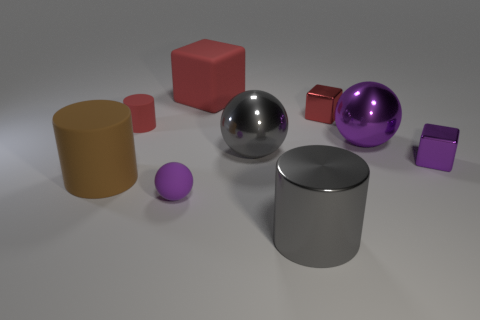The large gray object that is behind the matte cylinder in front of the small matte thing that is on the left side of the rubber sphere is made of what material?
Your answer should be very brief. Metal. What number of objects are red rubber things that are to the left of the big red cube or large gray metallic things that are behind the large gray cylinder?
Ensure brevity in your answer.  2. What material is the tiny purple object that is the same shape as the small red metallic thing?
Provide a short and direct response. Metal. What number of metallic objects are either brown blocks or large balls?
Your answer should be very brief. 2. What is the shape of the purple thing that is made of the same material as the large brown cylinder?
Make the answer very short. Sphere. How many big brown objects have the same shape as the big red thing?
Offer a very short reply. 0. There is a small purple thing that is behind the brown object; does it have the same shape as the small red thing that is to the right of the large red cube?
Ensure brevity in your answer.  Yes. What number of things are big purple objects or metal objects that are in front of the small purple matte sphere?
Keep it short and to the point. 2. What shape is the object that is the same color as the big metallic cylinder?
Your answer should be compact. Sphere. What number of brown objects have the same size as the purple matte object?
Offer a terse response. 0. 